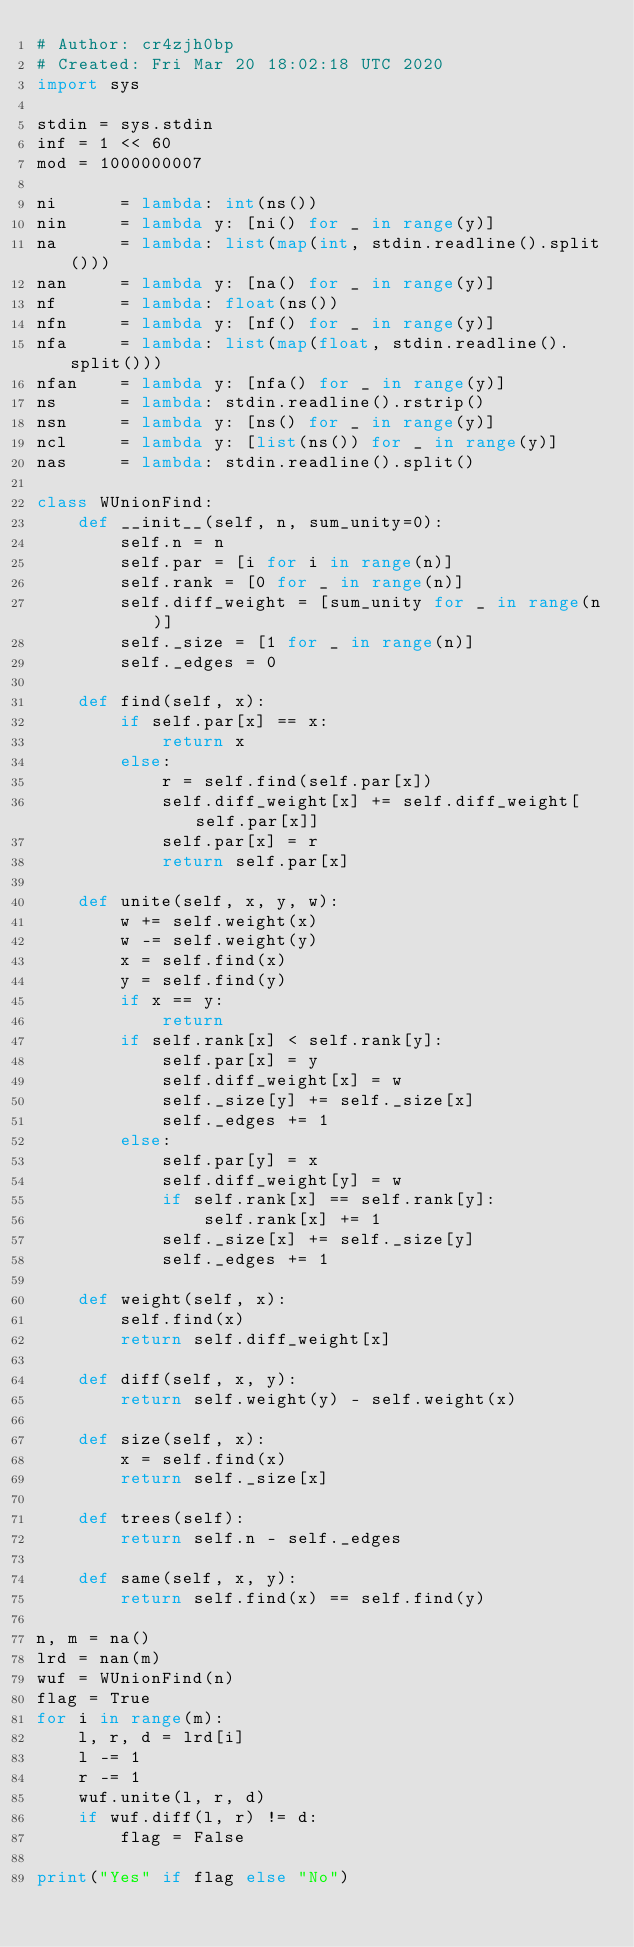Convert code to text. <code><loc_0><loc_0><loc_500><loc_500><_Python_># Author: cr4zjh0bp
# Created: Fri Mar 20 18:02:18 UTC 2020
import sys
 
stdin = sys.stdin
inf = 1 << 60
mod = 1000000007
 
ni      = lambda: int(ns())
nin     = lambda y: [ni() for _ in range(y)]
na      = lambda: list(map(int, stdin.readline().split()))
nan     = lambda y: [na() for _ in range(y)]
nf      = lambda: float(ns())
nfn     = lambda y: [nf() for _ in range(y)]
nfa     = lambda: list(map(float, stdin.readline().split()))
nfan    = lambda y: [nfa() for _ in range(y)]
ns      = lambda: stdin.readline().rstrip()
nsn     = lambda y: [ns() for _ in range(y)]
ncl     = lambda y: [list(ns()) for _ in range(y)]
nas     = lambda: stdin.readline().split()

class WUnionFind:
    def __init__(self, n, sum_unity=0):
        self.n = n
        self.par = [i for i in range(n)]
        self.rank = [0 for _ in range(n)]
        self.diff_weight = [sum_unity for _ in range(n)]
        self._size = [1 for _ in range(n)]
        self._edges = 0

    def find(self, x):
        if self.par[x] == x:
            return x
        else:
            r = self.find(self.par[x])
            self.diff_weight[x] += self.diff_weight[self.par[x]]
            self.par[x] = r
            return self.par[x]
        
    def unite(self, x, y, w):
        w += self.weight(x)
        w -= self.weight(y)
        x = self.find(x)
        y = self.find(y)
        if x == y:
            return
        if self.rank[x] < self.rank[y]:
            self.par[x] = y
            self.diff_weight[x] = w
            self._size[y] += self._size[x]
            self._edges += 1
        else:
            self.par[y] = x
            self.diff_weight[y] = w
            if self.rank[x] == self.rank[y]:
                self.rank[x] += 1
            self._size[x] += self._size[y]
            self._edges += 1

    def weight(self, x):
        self.find(x)
        return self.diff_weight[x]

    def diff(self, x, y):
        return self.weight(y) - self.weight(x)
    
    def size(self, x):
        x = self.find(x)
        return self._size[x]
    
    def trees(self):
        return self.n - self._edges

    def same(self, x, y):
        return self.find(x) == self.find(y)

n, m = na()
lrd = nan(m)
wuf = WUnionFind(n)
flag = True
for i in range(m):
    l, r, d = lrd[i]
    l -= 1
    r -= 1
    wuf.unite(l, r, d)
    if wuf.diff(l, r) != d:
        flag = False

print("Yes" if flag else "No")</code> 